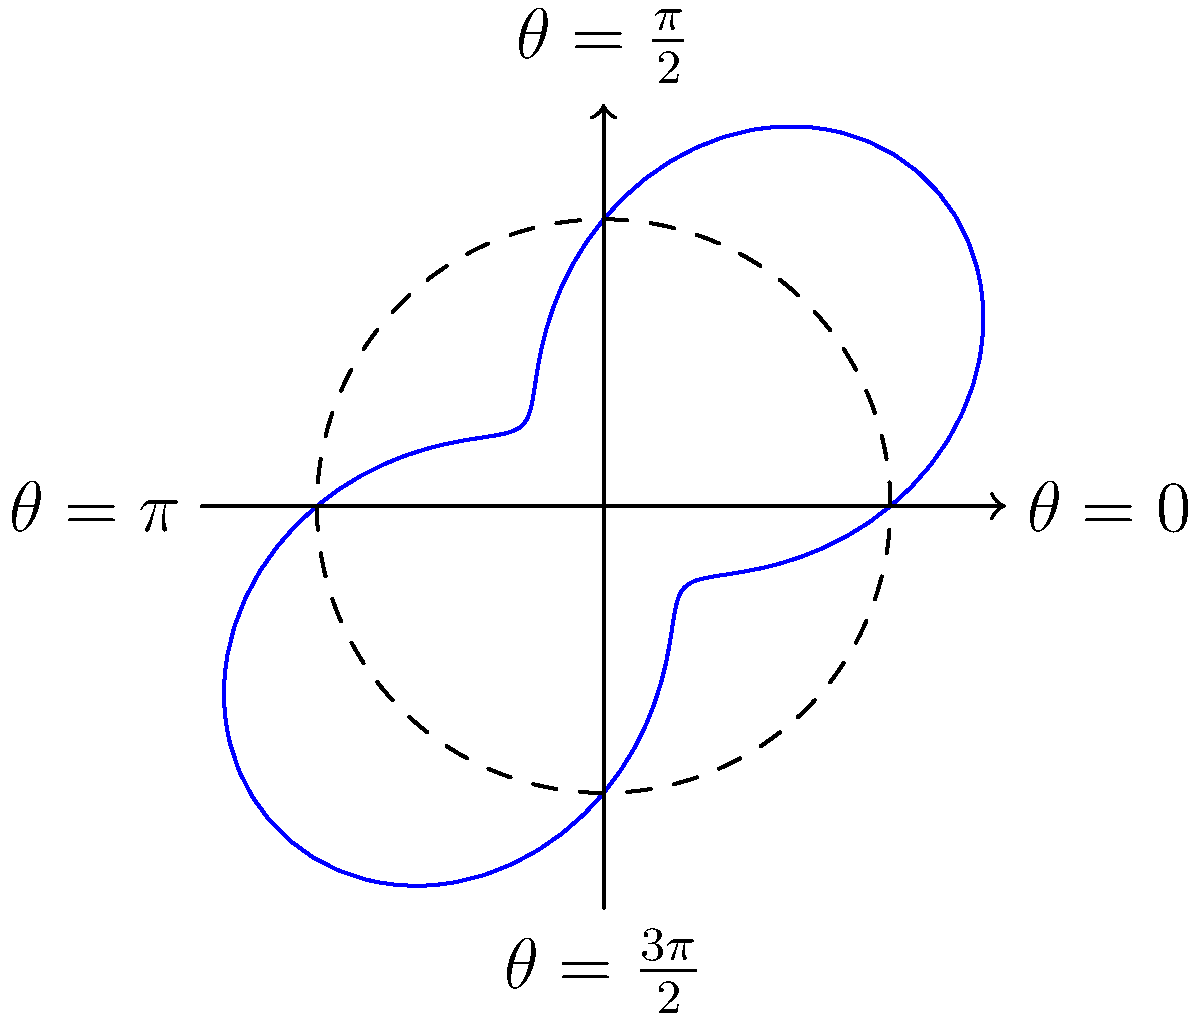A property developer is analyzing value trends across different areas of the Bronx using a polar curve model. The curve is given by the equation $r = 5 + 3\sin(2\theta)$, where $r$ represents property value (in hundreds of thousands of dollars) and $\theta$ represents the angular position in the borough. At which angular position(s) does the property value reach its maximum, and what is this maximum value? To solve this problem, we need to follow these steps:

1) The maximum value will occur when $\sin(2\theta)$ is at its maximum, which is 1.

2) $\sin(2\theta) = 1$ occurs when $2\theta = \frac{\pi}{2}$ or $\frac{3\pi}{2}$.

3) Solving for $\theta$:
   When $2\theta = \frac{\pi}{2}$, $\theta = \frac{\pi}{4}$
   When $2\theta = \frac{3\pi}{2}$, $\theta = \frac{3\pi}{4}$

4) To find the maximum value, we substitute $\sin(2\theta) = 1$ into the equation:
   $r_{max} = 5 + 3(1) = 8$

5) Converting back to actual property value:
   $8 \times 100,000 = 800,000$

Therefore, the property value reaches its maximum of $800,000 at two angular positions: $\frac{\pi}{4}$ and $\frac{3\pi}{4}$ radians.
Answer: $\theta = \frac{\pi}{4}$ and $\frac{3\pi}{4}$; $800,000 